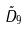Convert formula to latex. <formula><loc_0><loc_0><loc_500><loc_500>\tilde { D } _ { 9 }</formula> 